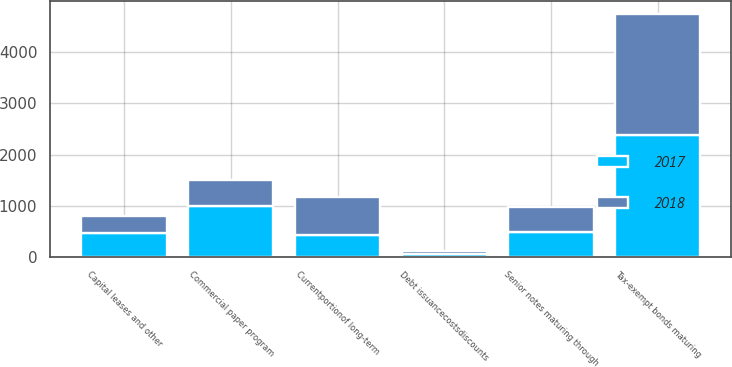Convert chart. <chart><loc_0><loc_0><loc_500><loc_500><stacked_bar_chart><ecel><fcel>Commercial paper program<fcel>Senior notes maturing through<fcel>Tax-exempt bonds maturing<fcel>Capital leases and other<fcel>Debt issuancecostsdiscounts<fcel>Currentportionof long-term<nl><fcel>2017<fcel>990<fcel>491<fcel>2388<fcel>467<fcel>52<fcel>432<nl><fcel>2018<fcel>515<fcel>491<fcel>2370<fcel>327<fcel>56<fcel>739<nl></chart> 